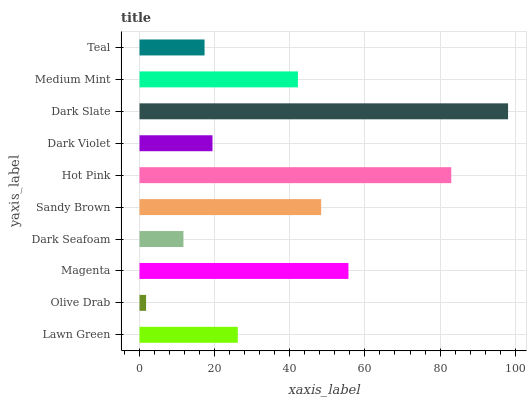Is Olive Drab the minimum?
Answer yes or no. Yes. Is Dark Slate the maximum?
Answer yes or no. Yes. Is Magenta the minimum?
Answer yes or no. No. Is Magenta the maximum?
Answer yes or no. No. Is Magenta greater than Olive Drab?
Answer yes or no. Yes. Is Olive Drab less than Magenta?
Answer yes or no. Yes. Is Olive Drab greater than Magenta?
Answer yes or no. No. Is Magenta less than Olive Drab?
Answer yes or no. No. Is Medium Mint the high median?
Answer yes or no. Yes. Is Lawn Green the low median?
Answer yes or no. Yes. Is Lawn Green the high median?
Answer yes or no. No. Is Olive Drab the low median?
Answer yes or no. No. 